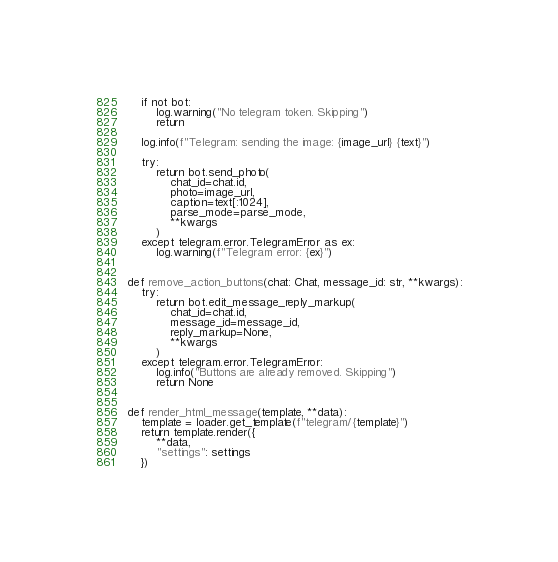<code> <loc_0><loc_0><loc_500><loc_500><_Python_>    if not bot:
        log.warning("No telegram token. Skipping")
        return

    log.info(f"Telegram: sending the image: {image_url} {text}")

    try:
        return bot.send_photo(
            chat_id=chat.id,
            photo=image_url,
            caption=text[:1024],
            parse_mode=parse_mode,
            **kwargs
        )
    except telegram.error.TelegramError as ex:
        log.warning(f"Telegram error: {ex}")


def remove_action_buttons(chat: Chat, message_id: str, **kwargs):
    try:
        return bot.edit_message_reply_markup(
            chat_id=chat.id,
            message_id=message_id,
            reply_markup=None,
            **kwargs
        )
    except telegram.error.TelegramError:
        log.info("Buttons are already removed. Skipping")
        return None


def render_html_message(template, **data):
    template = loader.get_template(f"telegram/{template}")
    return template.render({
        **data,
        "settings": settings
    })
</code> 